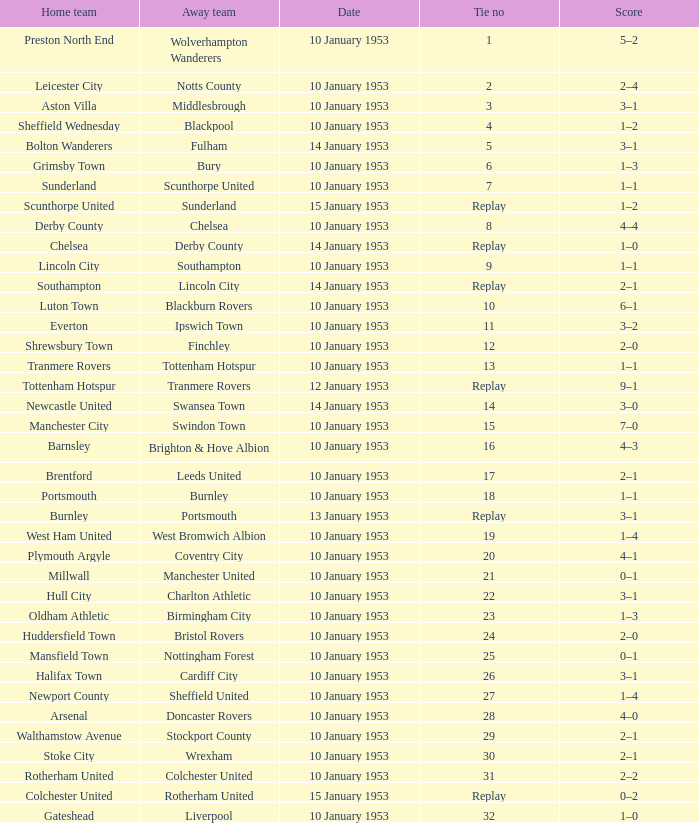What score has charlton athletic as the away team? 3–1. 